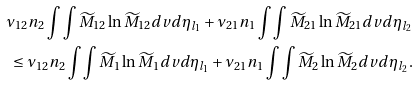<formula> <loc_0><loc_0><loc_500><loc_500>\nu _ { 1 2 } n _ { 2 } \int \int \widetilde { M } _ { 1 2 } \ln \widetilde { M } _ { 1 2 } d v d \eta _ { l _ { 1 } } + \nu _ { 2 1 } n _ { 1 } \int \int \widetilde { M } _ { 2 1 } \ln \widetilde { M } _ { 2 1 } d v d \eta _ { l _ { 2 } } \\ \leq \nu _ { 1 2 } n _ { 2 } \int \int \widetilde { M } _ { 1 } \ln \widetilde { M } _ { 1 } d v d \eta _ { l _ { 1 } } + \nu _ { 2 1 } n _ { 1 } \int \int \widetilde { M } _ { 2 } \ln \widetilde { M } _ { 2 } d v d \eta _ { l _ { 2 } } .</formula> 